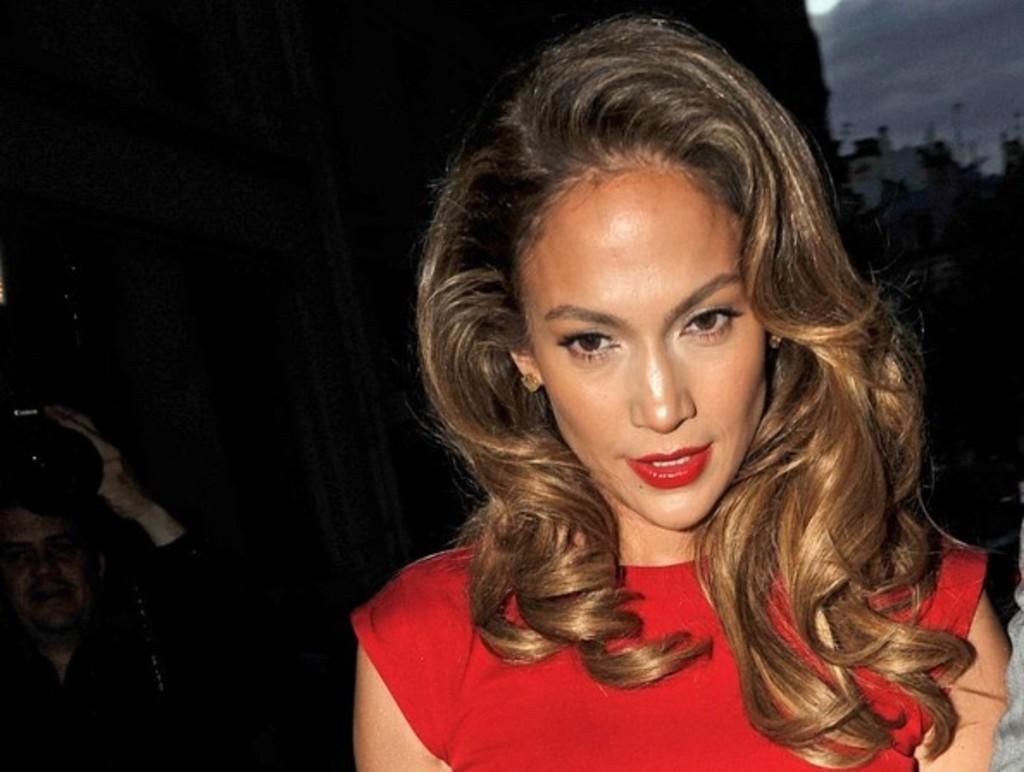Describe this image in one or two sentences. Here we can see a woman and there is a man holding a camera. There is a dark background. 